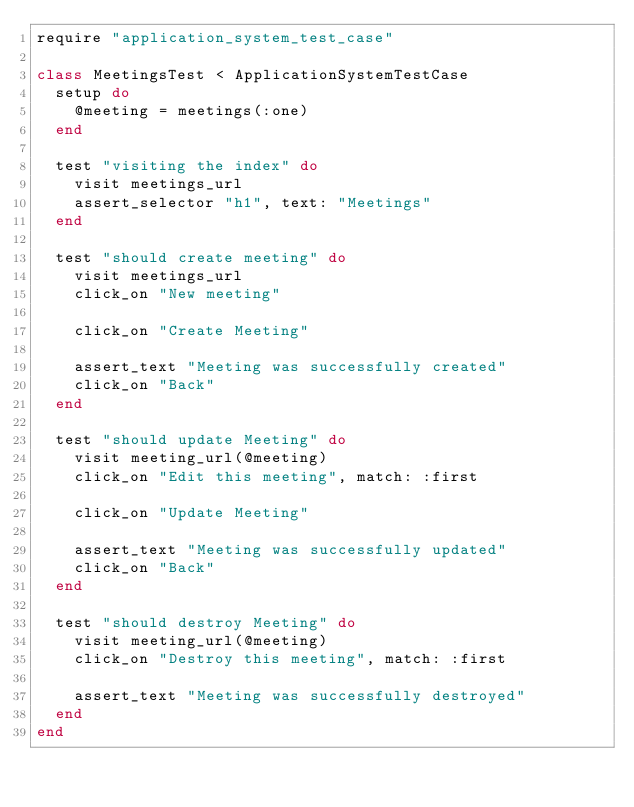<code> <loc_0><loc_0><loc_500><loc_500><_Ruby_>require "application_system_test_case"

class MeetingsTest < ApplicationSystemTestCase
  setup do
    @meeting = meetings(:one)
  end

  test "visiting the index" do
    visit meetings_url
    assert_selector "h1", text: "Meetings"
  end

  test "should create meeting" do
    visit meetings_url
    click_on "New meeting"

    click_on "Create Meeting"

    assert_text "Meeting was successfully created"
    click_on "Back"
  end

  test "should update Meeting" do
    visit meeting_url(@meeting)
    click_on "Edit this meeting", match: :first

    click_on "Update Meeting"

    assert_text "Meeting was successfully updated"
    click_on "Back"
  end

  test "should destroy Meeting" do
    visit meeting_url(@meeting)
    click_on "Destroy this meeting", match: :first

    assert_text "Meeting was successfully destroyed"
  end
end
</code> 